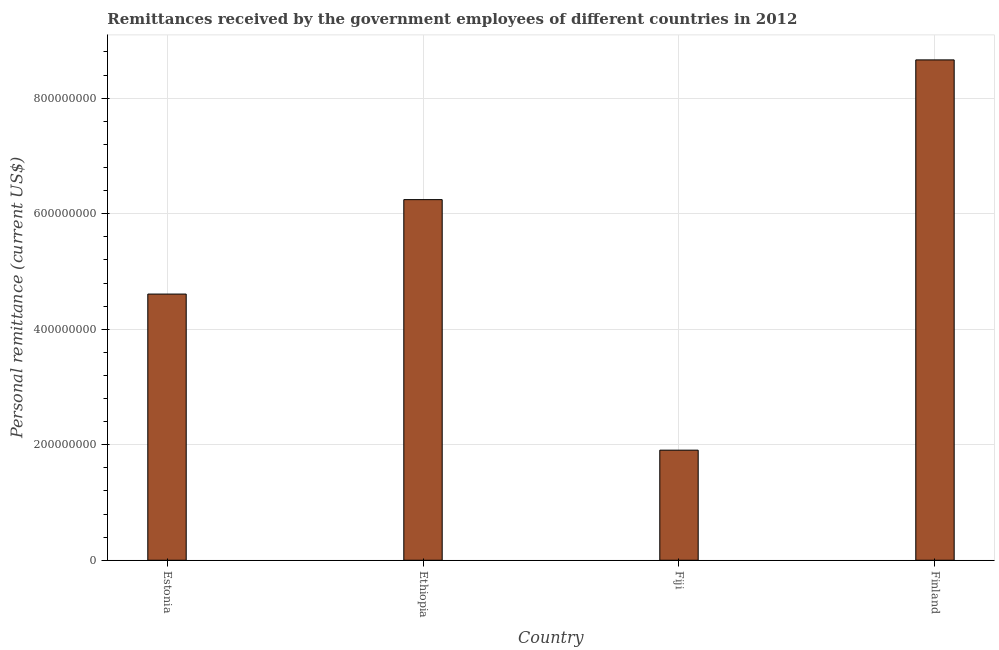Does the graph contain grids?
Offer a terse response. Yes. What is the title of the graph?
Provide a succinct answer. Remittances received by the government employees of different countries in 2012. What is the label or title of the X-axis?
Make the answer very short. Country. What is the label or title of the Y-axis?
Keep it short and to the point. Personal remittance (current US$). What is the personal remittances in Fiji?
Your answer should be compact. 1.91e+08. Across all countries, what is the maximum personal remittances?
Ensure brevity in your answer.  8.66e+08. Across all countries, what is the minimum personal remittances?
Provide a short and direct response. 1.91e+08. In which country was the personal remittances maximum?
Your answer should be very brief. Finland. In which country was the personal remittances minimum?
Make the answer very short. Fiji. What is the sum of the personal remittances?
Your response must be concise. 2.14e+09. What is the difference between the personal remittances in Estonia and Fiji?
Provide a succinct answer. 2.70e+08. What is the average personal remittances per country?
Provide a succinct answer. 5.36e+08. What is the median personal remittances?
Provide a succinct answer. 5.43e+08. In how many countries, is the personal remittances greater than 280000000 US$?
Make the answer very short. 3. What is the ratio of the personal remittances in Estonia to that in Ethiopia?
Give a very brief answer. 0.74. Is the personal remittances in Estonia less than that in Finland?
Ensure brevity in your answer.  Yes. What is the difference between the highest and the second highest personal remittances?
Your answer should be very brief. 2.42e+08. Is the sum of the personal remittances in Estonia and Fiji greater than the maximum personal remittances across all countries?
Make the answer very short. No. What is the difference between the highest and the lowest personal remittances?
Your response must be concise. 6.76e+08. How many bars are there?
Make the answer very short. 4. How many countries are there in the graph?
Offer a terse response. 4. Are the values on the major ticks of Y-axis written in scientific E-notation?
Offer a very short reply. No. What is the Personal remittance (current US$) of Estonia?
Provide a short and direct response. 4.61e+08. What is the Personal remittance (current US$) in Ethiopia?
Provide a short and direct response. 6.24e+08. What is the Personal remittance (current US$) in Fiji?
Your answer should be compact. 1.91e+08. What is the Personal remittance (current US$) in Finland?
Ensure brevity in your answer.  8.66e+08. What is the difference between the Personal remittance (current US$) in Estonia and Ethiopia?
Offer a very short reply. -1.64e+08. What is the difference between the Personal remittance (current US$) in Estonia and Fiji?
Make the answer very short. 2.70e+08. What is the difference between the Personal remittance (current US$) in Estonia and Finland?
Your response must be concise. -4.05e+08. What is the difference between the Personal remittance (current US$) in Ethiopia and Fiji?
Offer a very short reply. 4.34e+08. What is the difference between the Personal remittance (current US$) in Ethiopia and Finland?
Provide a succinct answer. -2.42e+08. What is the difference between the Personal remittance (current US$) in Fiji and Finland?
Your response must be concise. -6.76e+08. What is the ratio of the Personal remittance (current US$) in Estonia to that in Ethiopia?
Give a very brief answer. 0.74. What is the ratio of the Personal remittance (current US$) in Estonia to that in Fiji?
Ensure brevity in your answer.  2.42. What is the ratio of the Personal remittance (current US$) in Estonia to that in Finland?
Offer a very short reply. 0.53. What is the ratio of the Personal remittance (current US$) in Ethiopia to that in Fiji?
Your answer should be compact. 3.28. What is the ratio of the Personal remittance (current US$) in Ethiopia to that in Finland?
Provide a short and direct response. 0.72. What is the ratio of the Personal remittance (current US$) in Fiji to that in Finland?
Your answer should be very brief. 0.22. 